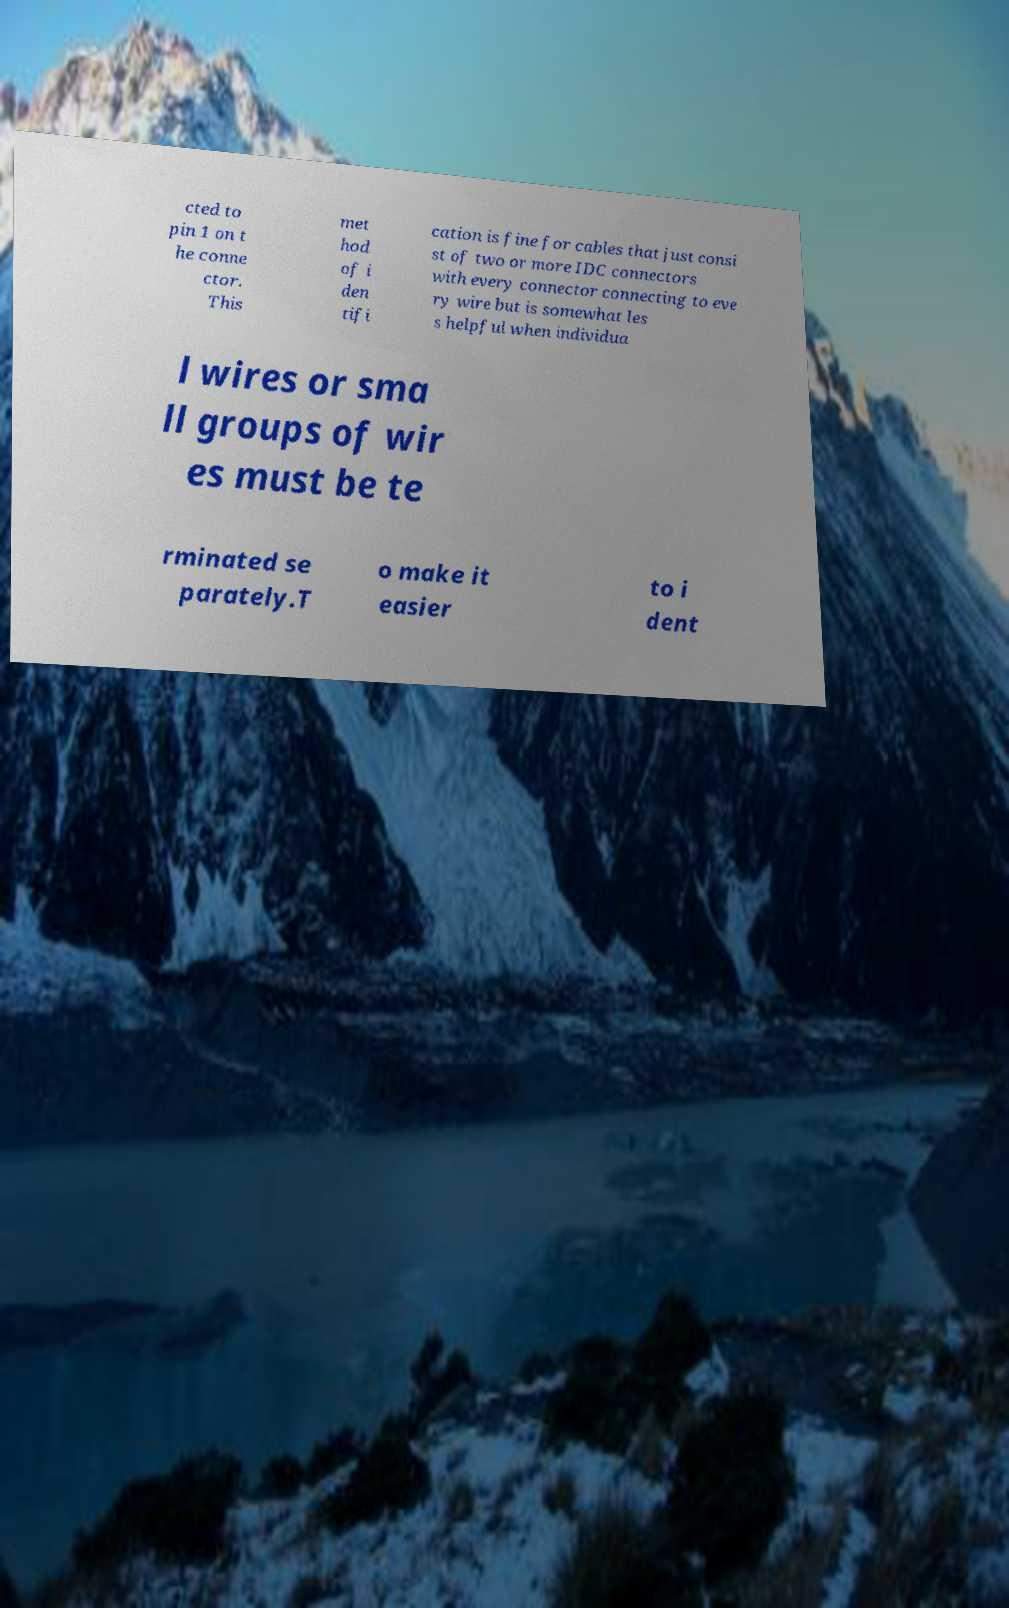There's text embedded in this image that I need extracted. Can you transcribe it verbatim? cted to pin 1 on t he conne ctor. This met hod of i den tifi cation is fine for cables that just consi st of two or more IDC connectors with every connector connecting to eve ry wire but is somewhat les s helpful when individua l wires or sma ll groups of wir es must be te rminated se parately.T o make it easier to i dent 